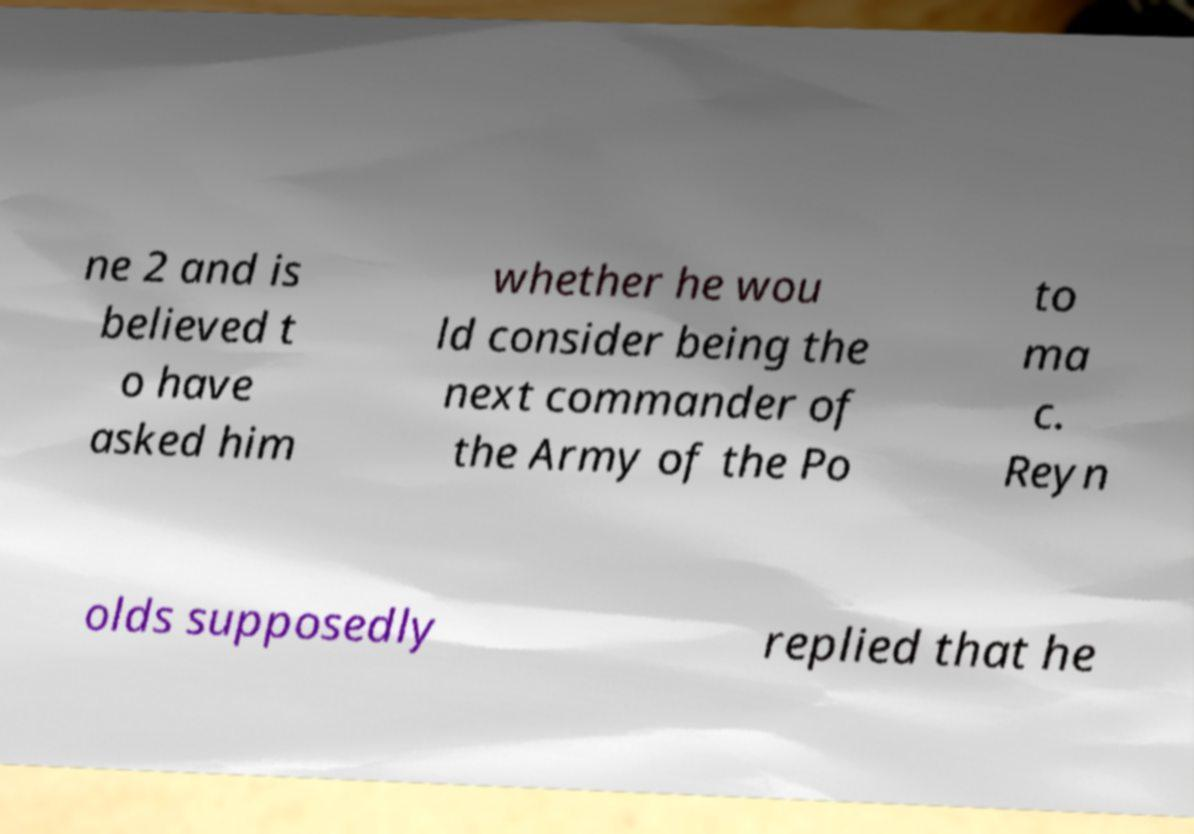There's text embedded in this image that I need extracted. Can you transcribe it verbatim? ne 2 and is believed t o have asked him whether he wou ld consider being the next commander of the Army of the Po to ma c. Reyn olds supposedly replied that he 